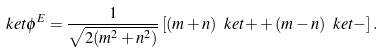Convert formula to latex. <formula><loc_0><loc_0><loc_500><loc_500>\ k e t { \phi ^ { E } } = \frac { 1 } { \sqrt { 2 ( m ^ { 2 } + n ^ { 2 } ) } } \left [ ( m + n ) \ k e t { + } + ( m - n ) \ k e t { - } \right ] .</formula> 